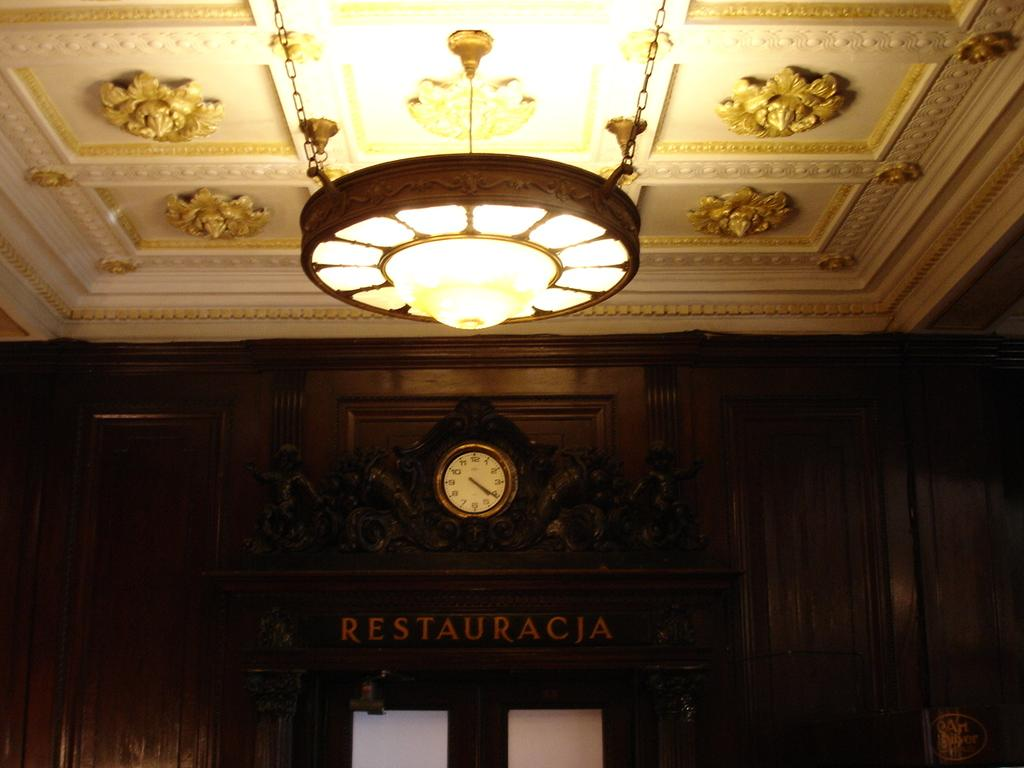<image>
Write a terse but informative summary of the picture. The clock above the doors to Restaracja says it's 4:20. 